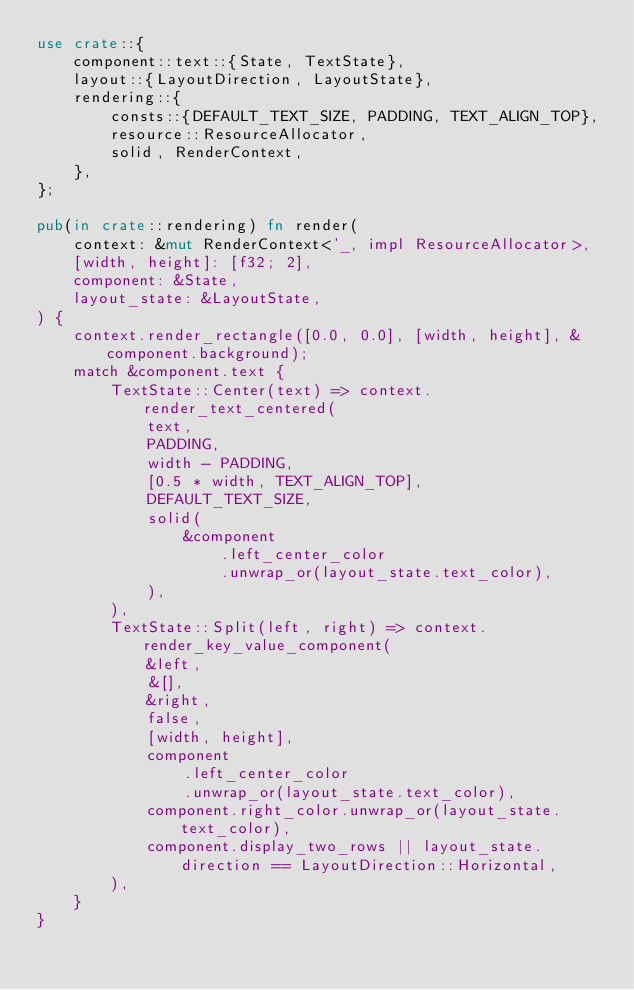Convert code to text. <code><loc_0><loc_0><loc_500><loc_500><_Rust_>use crate::{
    component::text::{State, TextState},
    layout::{LayoutDirection, LayoutState},
    rendering::{
        consts::{DEFAULT_TEXT_SIZE, PADDING, TEXT_ALIGN_TOP},
        resource::ResourceAllocator,
        solid, RenderContext,
    },
};

pub(in crate::rendering) fn render(
    context: &mut RenderContext<'_, impl ResourceAllocator>,
    [width, height]: [f32; 2],
    component: &State,
    layout_state: &LayoutState,
) {
    context.render_rectangle([0.0, 0.0], [width, height], &component.background);
    match &component.text {
        TextState::Center(text) => context.render_text_centered(
            text,
            PADDING,
            width - PADDING,
            [0.5 * width, TEXT_ALIGN_TOP],
            DEFAULT_TEXT_SIZE,
            solid(
                &component
                    .left_center_color
                    .unwrap_or(layout_state.text_color),
            ),
        ),
        TextState::Split(left, right) => context.render_key_value_component(
            &left,
            &[],
            &right,
            false,
            [width, height],
            component
                .left_center_color
                .unwrap_or(layout_state.text_color),
            component.right_color.unwrap_or(layout_state.text_color),
            component.display_two_rows || layout_state.direction == LayoutDirection::Horizontal,
        ),
    }
}
</code> 